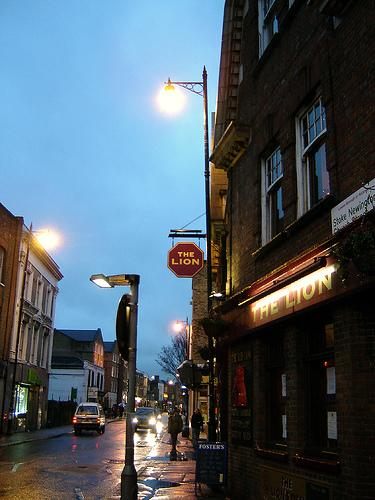Which sign will be easier for someone way down the street to spot?

Choices:
A) frame
B) rectangle
C) octagon
D) flyers octagon 